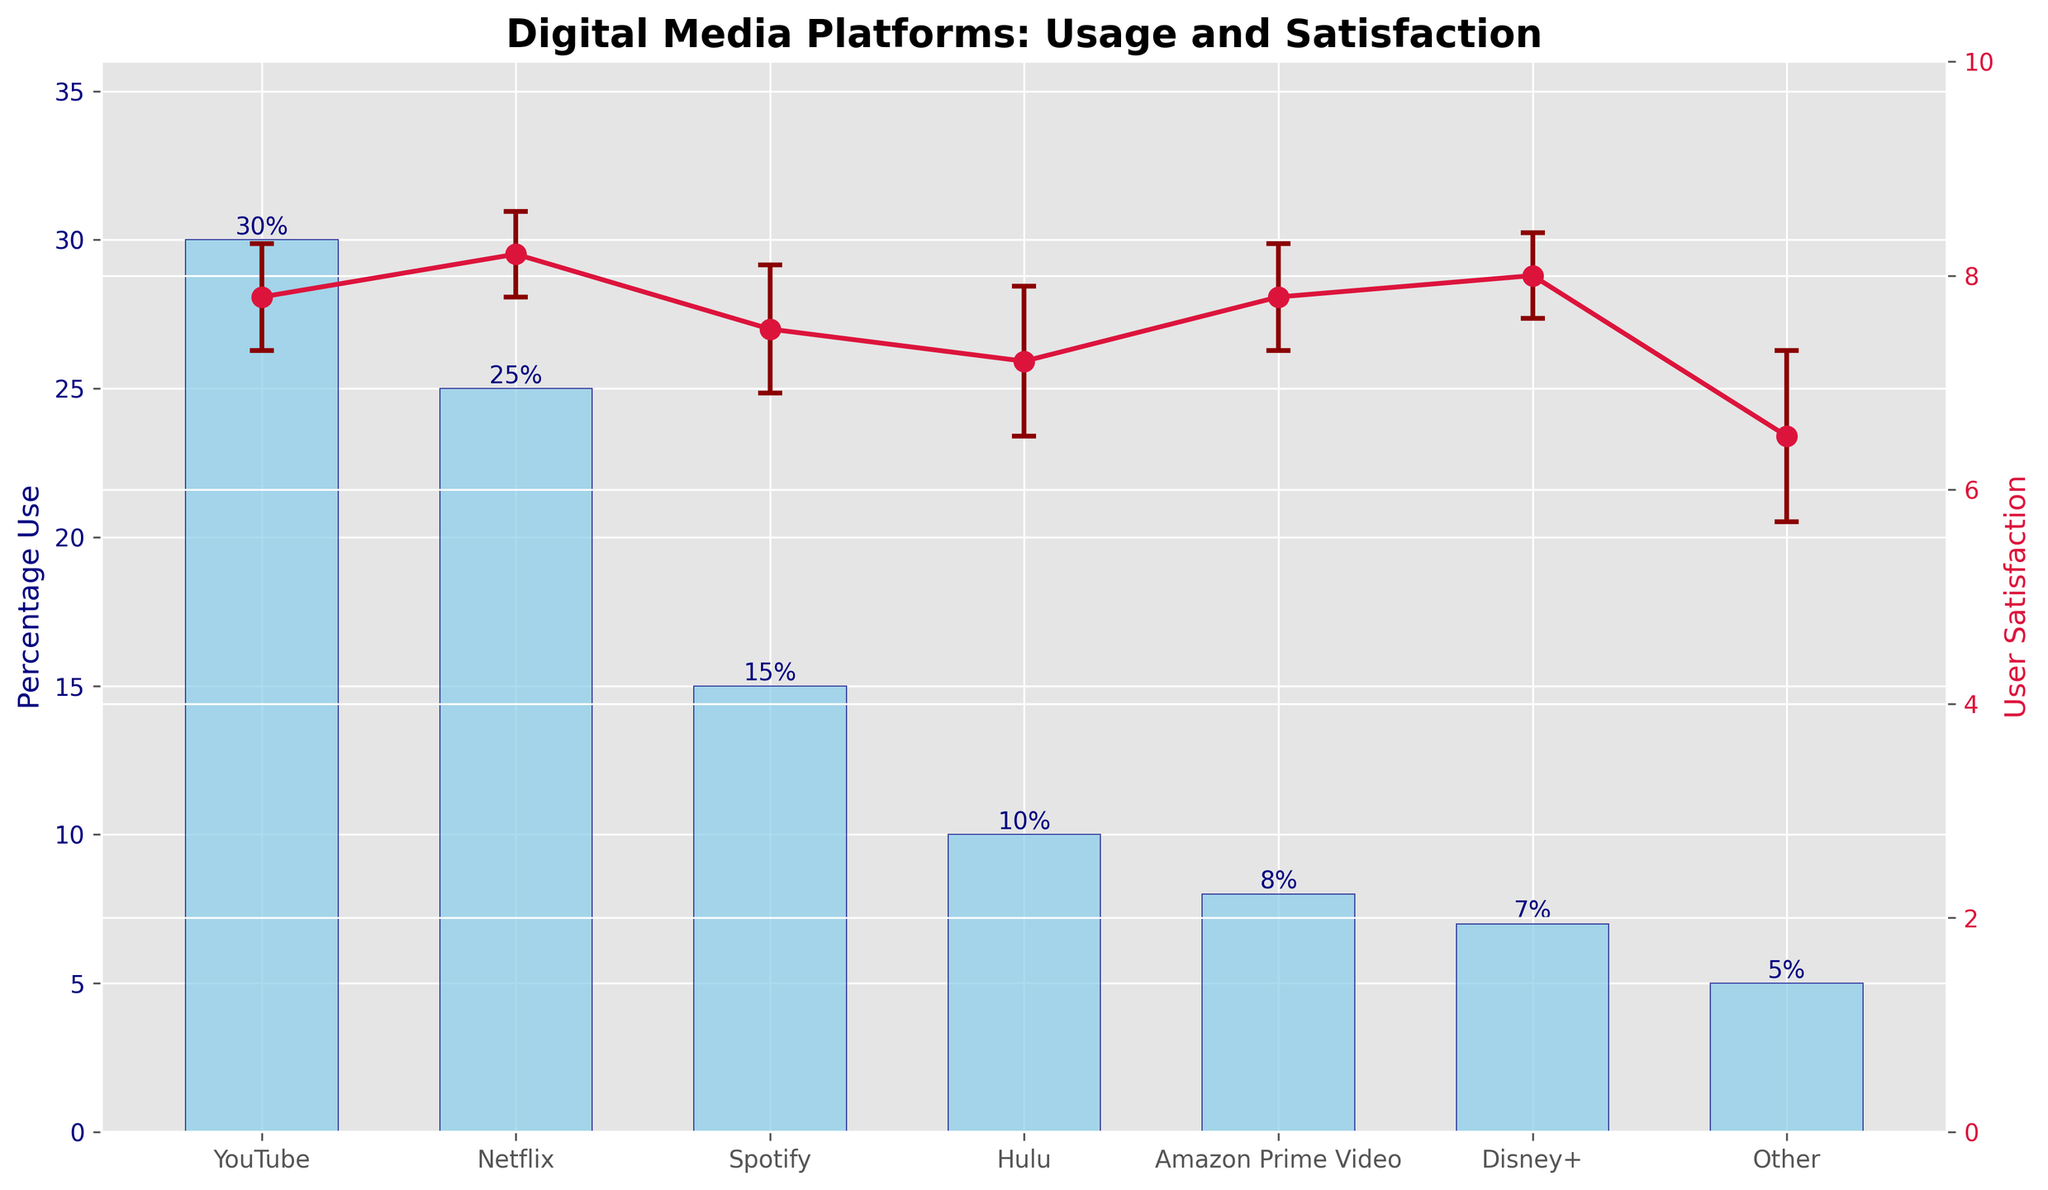Which platform has the highest percentage of use? The bar for YouTube is the tallest among the platforms in the bar chart.
Answer: YouTube Which has higher user satisfaction, Hulu or Disney+? The error bars show the mean satisfaction and its variations. Disney+ has a mean satisfaction of 8.0, higher than Hulu's 7.2.
Answer: Disney+ What is the mean user satisfaction for Spotify? The average user satisfaction for Spotify is marked on the line plot as 7.5.
Answer: 7.5 What is the percentage use for Netflix? The bar for Netflix shows a height corresponding to 25%.
Answer: 25% Which platform has the lowest user satisfaction? The line plot and respective error bars indicate that the 'Other' category has the lowest mean satisfaction at 6.5.
Answer: Other What is the difference in mean user satisfaction between YouTube and Amazon Prime Video? The mean satisfaction for both YouTube and Amazon Prime Video is 7.8. Therefore, the difference is 7.8 - 7.8 = 0.
Answer: 0 How many platforms have a mean user satisfaction of 8 or higher? Netflix (8.2), Disney+ (8.0), and Amazon Prime Video (8.0) are all ≥ 8 based on the line plot.
Answer: 3 Which platform has the highest satisfaction standard deviation? The length of the error bars indicates that 'Other' has the largest standard deviation at 0.8.
Answer: Other What is the combined percentage of use for Amazon Prime Video and Disney+? Adding the percentages for Amazon Prime Video (8%) and Disney+ (7%), we get 8 + 7 = 15%.
Answer: 15% Comparing YouTube and Hulu, which has a higher percentage of use and a lower standard deviation in satisfaction? YouTube has a higher percentage of use at 30% compared to Hulu's 10%. YouTube also has a lower satisfaction standard deviation of 0.5 compared to Hulu's 0.7.
Answer: YouTube 